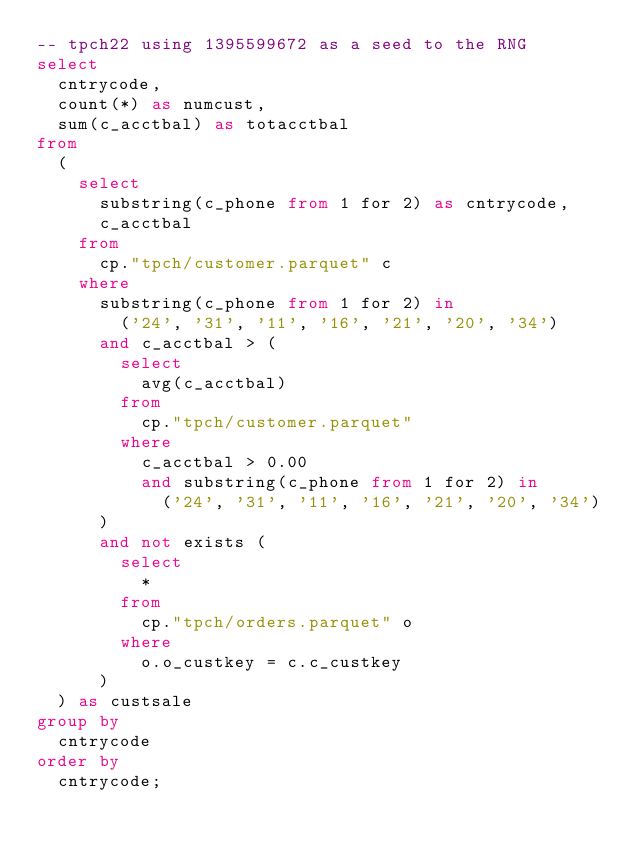<code> <loc_0><loc_0><loc_500><loc_500><_SQL_>-- tpch22 using 1395599672 as a seed to the RNG
select
  cntrycode,
  count(*) as numcust,
  sum(c_acctbal) as totacctbal
from
  (
    select
      substring(c_phone from 1 for 2) as cntrycode,
      c_acctbal
    from
      cp."tpch/customer.parquet" c
    where
      substring(c_phone from 1 for 2) in
        ('24', '31', '11', '16', '21', '20', '34')
      and c_acctbal > (
        select
          avg(c_acctbal)
        from
          cp."tpch/customer.parquet"
        where
          c_acctbal > 0.00
          and substring(c_phone from 1 for 2) in
            ('24', '31', '11', '16', '21', '20', '34')
      )
      and not exists (
        select
          *
        from
          cp."tpch/orders.parquet" o
        where
          o.o_custkey = c.c_custkey
      )
  ) as custsale
group by
  cntrycode
order by
  cntrycode;
</code> 